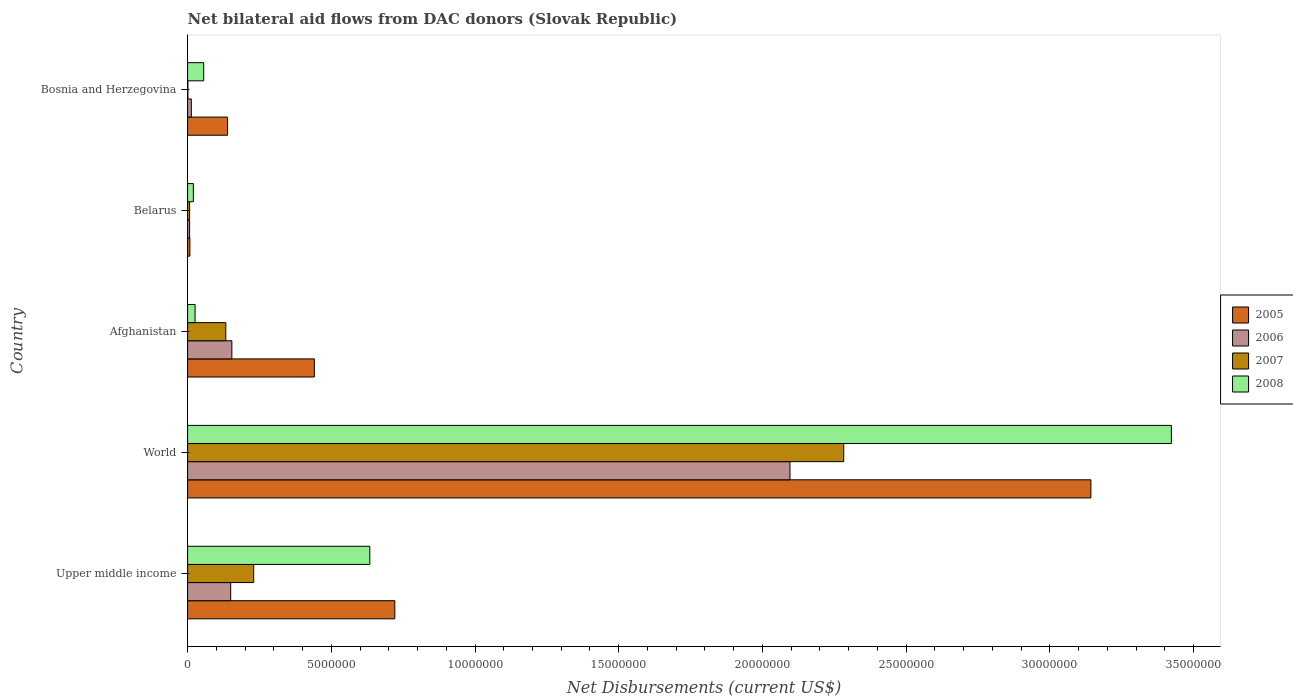How many different coloured bars are there?
Offer a terse response. 4. How many bars are there on the 3rd tick from the bottom?
Your answer should be very brief. 4. What is the label of the 5th group of bars from the top?
Give a very brief answer. Upper middle income. Across all countries, what is the maximum net bilateral aid flows in 2007?
Your answer should be compact. 2.28e+07. In which country was the net bilateral aid flows in 2005 minimum?
Provide a succinct answer. Belarus. What is the total net bilateral aid flows in 2006 in the graph?
Your answer should be very brief. 2.42e+07. What is the difference between the net bilateral aid flows in 2008 in Bosnia and Herzegovina and that in Upper middle income?
Ensure brevity in your answer.  -5.78e+06. What is the difference between the net bilateral aid flows in 2005 in Belarus and the net bilateral aid flows in 2008 in Bosnia and Herzegovina?
Ensure brevity in your answer.  -4.80e+05. What is the average net bilateral aid flows in 2005 per country?
Make the answer very short. 8.90e+06. What is the difference between the net bilateral aid flows in 2007 and net bilateral aid flows in 2006 in Afghanistan?
Provide a short and direct response. -2.10e+05. In how many countries, is the net bilateral aid flows in 2007 greater than 26000000 US$?
Your response must be concise. 0. What is the ratio of the net bilateral aid flows in 2005 in Bosnia and Herzegovina to that in Upper middle income?
Offer a very short reply. 0.19. Is the difference between the net bilateral aid flows in 2007 in Afghanistan and Upper middle income greater than the difference between the net bilateral aid flows in 2006 in Afghanistan and Upper middle income?
Ensure brevity in your answer.  No. What is the difference between the highest and the second highest net bilateral aid flows in 2005?
Make the answer very short. 2.42e+07. What is the difference between the highest and the lowest net bilateral aid flows in 2007?
Your response must be concise. 2.28e+07. Is the sum of the net bilateral aid flows in 2008 in Afghanistan and Bosnia and Herzegovina greater than the maximum net bilateral aid flows in 2005 across all countries?
Provide a succinct answer. No. Is it the case that in every country, the sum of the net bilateral aid flows in 2008 and net bilateral aid flows in 2005 is greater than the sum of net bilateral aid flows in 2007 and net bilateral aid flows in 2006?
Make the answer very short. No. What does the 2nd bar from the bottom in Afghanistan represents?
Provide a succinct answer. 2006. How many bars are there?
Your response must be concise. 20. How many countries are there in the graph?
Ensure brevity in your answer.  5. Where does the legend appear in the graph?
Provide a short and direct response. Center right. What is the title of the graph?
Offer a terse response. Net bilateral aid flows from DAC donors (Slovak Republic). Does "1976" appear as one of the legend labels in the graph?
Offer a terse response. No. What is the label or title of the X-axis?
Ensure brevity in your answer.  Net Disbursements (current US$). What is the Net Disbursements (current US$) in 2005 in Upper middle income?
Provide a succinct answer. 7.21e+06. What is the Net Disbursements (current US$) in 2006 in Upper middle income?
Your answer should be very brief. 1.50e+06. What is the Net Disbursements (current US$) in 2007 in Upper middle income?
Ensure brevity in your answer.  2.30e+06. What is the Net Disbursements (current US$) of 2008 in Upper middle income?
Offer a very short reply. 6.34e+06. What is the Net Disbursements (current US$) in 2005 in World?
Provide a short and direct response. 3.14e+07. What is the Net Disbursements (current US$) of 2006 in World?
Make the answer very short. 2.10e+07. What is the Net Disbursements (current US$) in 2007 in World?
Your answer should be compact. 2.28e+07. What is the Net Disbursements (current US$) of 2008 in World?
Keep it short and to the point. 3.42e+07. What is the Net Disbursements (current US$) in 2005 in Afghanistan?
Provide a short and direct response. 4.41e+06. What is the Net Disbursements (current US$) in 2006 in Afghanistan?
Offer a terse response. 1.54e+06. What is the Net Disbursements (current US$) in 2007 in Afghanistan?
Give a very brief answer. 1.33e+06. What is the Net Disbursements (current US$) of 2008 in Afghanistan?
Make the answer very short. 2.60e+05. What is the Net Disbursements (current US$) of 2005 in Belarus?
Make the answer very short. 8.00e+04. What is the Net Disbursements (current US$) in 2008 in Belarus?
Provide a succinct answer. 2.00e+05. What is the Net Disbursements (current US$) of 2005 in Bosnia and Herzegovina?
Make the answer very short. 1.39e+06. What is the Net Disbursements (current US$) of 2006 in Bosnia and Herzegovina?
Provide a short and direct response. 1.30e+05. What is the Net Disbursements (current US$) in 2008 in Bosnia and Herzegovina?
Keep it short and to the point. 5.60e+05. Across all countries, what is the maximum Net Disbursements (current US$) in 2005?
Ensure brevity in your answer.  3.14e+07. Across all countries, what is the maximum Net Disbursements (current US$) of 2006?
Your answer should be compact. 2.10e+07. Across all countries, what is the maximum Net Disbursements (current US$) in 2007?
Offer a terse response. 2.28e+07. Across all countries, what is the maximum Net Disbursements (current US$) of 2008?
Provide a short and direct response. 3.42e+07. Across all countries, what is the minimum Net Disbursements (current US$) in 2006?
Offer a very short reply. 7.00e+04. Across all countries, what is the minimum Net Disbursements (current US$) of 2008?
Ensure brevity in your answer.  2.00e+05. What is the total Net Disbursements (current US$) in 2005 in the graph?
Provide a succinct answer. 4.45e+07. What is the total Net Disbursements (current US$) of 2006 in the graph?
Ensure brevity in your answer.  2.42e+07. What is the total Net Disbursements (current US$) of 2007 in the graph?
Your answer should be compact. 2.65e+07. What is the total Net Disbursements (current US$) in 2008 in the graph?
Ensure brevity in your answer.  4.16e+07. What is the difference between the Net Disbursements (current US$) of 2005 in Upper middle income and that in World?
Keep it short and to the point. -2.42e+07. What is the difference between the Net Disbursements (current US$) in 2006 in Upper middle income and that in World?
Ensure brevity in your answer.  -1.95e+07. What is the difference between the Net Disbursements (current US$) of 2007 in Upper middle income and that in World?
Ensure brevity in your answer.  -2.05e+07. What is the difference between the Net Disbursements (current US$) in 2008 in Upper middle income and that in World?
Make the answer very short. -2.79e+07. What is the difference between the Net Disbursements (current US$) of 2005 in Upper middle income and that in Afghanistan?
Your response must be concise. 2.80e+06. What is the difference between the Net Disbursements (current US$) in 2007 in Upper middle income and that in Afghanistan?
Your answer should be very brief. 9.70e+05. What is the difference between the Net Disbursements (current US$) of 2008 in Upper middle income and that in Afghanistan?
Offer a terse response. 6.08e+06. What is the difference between the Net Disbursements (current US$) of 2005 in Upper middle income and that in Belarus?
Keep it short and to the point. 7.13e+06. What is the difference between the Net Disbursements (current US$) in 2006 in Upper middle income and that in Belarus?
Make the answer very short. 1.43e+06. What is the difference between the Net Disbursements (current US$) in 2007 in Upper middle income and that in Belarus?
Offer a very short reply. 2.23e+06. What is the difference between the Net Disbursements (current US$) in 2008 in Upper middle income and that in Belarus?
Your answer should be very brief. 6.14e+06. What is the difference between the Net Disbursements (current US$) of 2005 in Upper middle income and that in Bosnia and Herzegovina?
Your answer should be compact. 5.82e+06. What is the difference between the Net Disbursements (current US$) of 2006 in Upper middle income and that in Bosnia and Herzegovina?
Provide a succinct answer. 1.37e+06. What is the difference between the Net Disbursements (current US$) of 2007 in Upper middle income and that in Bosnia and Herzegovina?
Provide a succinct answer. 2.29e+06. What is the difference between the Net Disbursements (current US$) in 2008 in Upper middle income and that in Bosnia and Herzegovina?
Your response must be concise. 5.78e+06. What is the difference between the Net Disbursements (current US$) of 2005 in World and that in Afghanistan?
Your answer should be very brief. 2.70e+07. What is the difference between the Net Disbursements (current US$) in 2006 in World and that in Afghanistan?
Make the answer very short. 1.94e+07. What is the difference between the Net Disbursements (current US$) of 2007 in World and that in Afghanistan?
Give a very brief answer. 2.15e+07. What is the difference between the Net Disbursements (current US$) of 2008 in World and that in Afghanistan?
Keep it short and to the point. 3.40e+07. What is the difference between the Net Disbursements (current US$) of 2005 in World and that in Belarus?
Your answer should be very brief. 3.14e+07. What is the difference between the Net Disbursements (current US$) of 2006 in World and that in Belarus?
Provide a short and direct response. 2.09e+07. What is the difference between the Net Disbursements (current US$) in 2007 in World and that in Belarus?
Your response must be concise. 2.28e+07. What is the difference between the Net Disbursements (current US$) of 2008 in World and that in Belarus?
Provide a succinct answer. 3.40e+07. What is the difference between the Net Disbursements (current US$) of 2005 in World and that in Bosnia and Herzegovina?
Offer a very short reply. 3.00e+07. What is the difference between the Net Disbursements (current US$) in 2006 in World and that in Bosnia and Herzegovina?
Provide a short and direct response. 2.08e+07. What is the difference between the Net Disbursements (current US$) of 2007 in World and that in Bosnia and Herzegovina?
Keep it short and to the point. 2.28e+07. What is the difference between the Net Disbursements (current US$) of 2008 in World and that in Bosnia and Herzegovina?
Provide a short and direct response. 3.37e+07. What is the difference between the Net Disbursements (current US$) in 2005 in Afghanistan and that in Belarus?
Offer a very short reply. 4.33e+06. What is the difference between the Net Disbursements (current US$) in 2006 in Afghanistan and that in Belarus?
Provide a succinct answer. 1.47e+06. What is the difference between the Net Disbursements (current US$) of 2007 in Afghanistan and that in Belarus?
Provide a succinct answer. 1.26e+06. What is the difference between the Net Disbursements (current US$) in 2005 in Afghanistan and that in Bosnia and Herzegovina?
Offer a very short reply. 3.02e+06. What is the difference between the Net Disbursements (current US$) in 2006 in Afghanistan and that in Bosnia and Herzegovina?
Your response must be concise. 1.41e+06. What is the difference between the Net Disbursements (current US$) of 2007 in Afghanistan and that in Bosnia and Herzegovina?
Your answer should be compact. 1.32e+06. What is the difference between the Net Disbursements (current US$) of 2005 in Belarus and that in Bosnia and Herzegovina?
Provide a short and direct response. -1.31e+06. What is the difference between the Net Disbursements (current US$) in 2006 in Belarus and that in Bosnia and Herzegovina?
Give a very brief answer. -6.00e+04. What is the difference between the Net Disbursements (current US$) in 2008 in Belarus and that in Bosnia and Herzegovina?
Provide a succinct answer. -3.60e+05. What is the difference between the Net Disbursements (current US$) of 2005 in Upper middle income and the Net Disbursements (current US$) of 2006 in World?
Your answer should be compact. -1.38e+07. What is the difference between the Net Disbursements (current US$) of 2005 in Upper middle income and the Net Disbursements (current US$) of 2007 in World?
Make the answer very short. -1.56e+07. What is the difference between the Net Disbursements (current US$) of 2005 in Upper middle income and the Net Disbursements (current US$) of 2008 in World?
Ensure brevity in your answer.  -2.70e+07. What is the difference between the Net Disbursements (current US$) of 2006 in Upper middle income and the Net Disbursements (current US$) of 2007 in World?
Your answer should be very brief. -2.13e+07. What is the difference between the Net Disbursements (current US$) in 2006 in Upper middle income and the Net Disbursements (current US$) in 2008 in World?
Keep it short and to the point. -3.27e+07. What is the difference between the Net Disbursements (current US$) in 2007 in Upper middle income and the Net Disbursements (current US$) in 2008 in World?
Your answer should be very brief. -3.19e+07. What is the difference between the Net Disbursements (current US$) in 2005 in Upper middle income and the Net Disbursements (current US$) in 2006 in Afghanistan?
Your answer should be very brief. 5.67e+06. What is the difference between the Net Disbursements (current US$) in 2005 in Upper middle income and the Net Disbursements (current US$) in 2007 in Afghanistan?
Keep it short and to the point. 5.88e+06. What is the difference between the Net Disbursements (current US$) of 2005 in Upper middle income and the Net Disbursements (current US$) of 2008 in Afghanistan?
Your answer should be very brief. 6.95e+06. What is the difference between the Net Disbursements (current US$) of 2006 in Upper middle income and the Net Disbursements (current US$) of 2008 in Afghanistan?
Ensure brevity in your answer.  1.24e+06. What is the difference between the Net Disbursements (current US$) of 2007 in Upper middle income and the Net Disbursements (current US$) of 2008 in Afghanistan?
Provide a succinct answer. 2.04e+06. What is the difference between the Net Disbursements (current US$) in 2005 in Upper middle income and the Net Disbursements (current US$) in 2006 in Belarus?
Ensure brevity in your answer.  7.14e+06. What is the difference between the Net Disbursements (current US$) in 2005 in Upper middle income and the Net Disbursements (current US$) in 2007 in Belarus?
Make the answer very short. 7.14e+06. What is the difference between the Net Disbursements (current US$) in 2005 in Upper middle income and the Net Disbursements (current US$) in 2008 in Belarus?
Keep it short and to the point. 7.01e+06. What is the difference between the Net Disbursements (current US$) in 2006 in Upper middle income and the Net Disbursements (current US$) in 2007 in Belarus?
Offer a terse response. 1.43e+06. What is the difference between the Net Disbursements (current US$) of 2006 in Upper middle income and the Net Disbursements (current US$) of 2008 in Belarus?
Make the answer very short. 1.30e+06. What is the difference between the Net Disbursements (current US$) of 2007 in Upper middle income and the Net Disbursements (current US$) of 2008 in Belarus?
Provide a short and direct response. 2.10e+06. What is the difference between the Net Disbursements (current US$) in 2005 in Upper middle income and the Net Disbursements (current US$) in 2006 in Bosnia and Herzegovina?
Your answer should be very brief. 7.08e+06. What is the difference between the Net Disbursements (current US$) in 2005 in Upper middle income and the Net Disbursements (current US$) in 2007 in Bosnia and Herzegovina?
Provide a succinct answer. 7.20e+06. What is the difference between the Net Disbursements (current US$) in 2005 in Upper middle income and the Net Disbursements (current US$) in 2008 in Bosnia and Herzegovina?
Make the answer very short. 6.65e+06. What is the difference between the Net Disbursements (current US$) in 2006 in Upper middle income and the Net Disbursements (current US$) in 2007 in Bosnia and Herzegovina?
Give a very brief answer. 1.49e+06. What is the difference between the Net Disbursements (current US$) in 2006 in Upper middle income and the Net Disbursements (current US$) in 2008 in Bosnia and Herzegovina?
Keep it short and to the point. 9.40e+05. What is the difference between the Net Disbursements (current US$) of 2007 in Upper middle income and the Net Disbursements (current US$) of 2008 in Bosnia and Herzegovina?
Keep it short and to the point. 1.74e+06. What is the difference between the Net Disbursements (current US$) of 2005 in World and the Net Disbursements (current US$) of 2006 in Afghanistan?
Your answer should be very brief. 2.99e+07. What is the difference between the Net Disbursements (current US$) of 2005 in World and the Net Disbursements (current US$) of 2007 in Afghanistan?
Offer a terse response. 3.01e+07. What is the difference between the Net Disbursements (current US$) of 2005 in World and the Net Disbursements (current US$) of 2008 in Afghanistan?
Make the answer very short. 3.12e+07. What is the difference between the Net Disbursements (current US$) of 2006 in World and the Net Disbursements (current US$) of 2007 in Afghanistan?
Make the answer very short. 1.96e+07. What is the difference between the Net Disbursements (current US$) in 2006 in World and the Net Disbursements (current US$) in 2008 in Afghanistan?
Your answer should be very brief. 2.07e+07. What is the difference between the Net Disbursements (current US$) of 2007 in World and the Net Disbursements (current US$) of 2008 in Afghanistan?
Provide a succinct answer. 2.26e+07. What is the difference between the Net Disbursements (current US$) of 2005 in World and the Net Disbursements (current US$) of 2006 in Belarus?
Your answer should be very brief. 3.14e+07. What is the difference between the Net Disbursements (current US$) in 2005 in World and the Net Disbursements (current US$) in 2007 in Belarus?
Keep it short and to the point. 3.14e+07. What is the difference between the Net Disbursements (current US$) of 2005 in World and the Net Disbursements (current US$) of 2008 in Belarus?
Your answer should be compact. 3.12e+07. What is the difference between the Net Disbursements (current US$) in 2006 in World and the Net Disbursements (current US$) in 2007 in Belarus?
Offer a very short reply. 2.09e+07. What is the difference between the Net Disbursements (current US$) of 2006 in World and the Net Disbursements (current US$) of 2008 in Belarus?
Your answer should be very brief. 2.08e+07. What is the difference between the Net Disbursements (current US$) in 2007 in World and the Net Disbursements (current US$) in 2008 in Belarus?
Offer a terse response. 2.26e+07. What is the difference between the Net Disbursements (current US$) of 2005 in World and the Net Disbursements (current US$) of 2006 in Bosnia and Herzegovina?
Your answer should be very brief. 3.13e+07. What is the difference between the Net Disbursements (current US$) in 2005 in World and the Net Disbursements (current US$) in 2007 in Bosnia and Herzegovina?
Provide a succinct answer. 3.14e+07. What is the difference between the Net Disbursements (current US$) of 2005 in World and the Net Disbursements (current US$) of 2008 in Bosnia and Herzegovina?
Keep it short and to the point. 3.09e+07. What is the difference between the Net Disbursements (current US$) of 2006 in World and the Net Disbursements (current US$) of 2007 in Bosnia and Herzegovina?
Give a very brief answer. 2.10e+07. What is the difference between the Net Disbursements (current US$) in 2006 in World and the Net Disbursements (current US$) in 2008 in Bosnia and Herzegovina?
Give a very brief answer. 2.04e+07. What is the difference between the Net Disbursements (current US$) of 2007 in World and the Net Disbursements (current US$) of 2008 in Bosnia and Herzegovina?
Ensure brevity in your answer.  2.23e+07. What is the difference between the Net Disbursements (current US$) of 2005 in Afghanistan and the Net Disbursements (current US$) of 2006 in Belarus?
Give a very brief answer. 4.34e+06. What is the difference between the Net Disbursements (current US$) in 2005 in Afghanistan and the Net Disbursements (current US$) in 2007 in Belarus?
Make the answer very short. 4.34e+06. What is the difference between the Net Disbursements (current US$) of 2005 in Afghanistan and the Net Disbursements (current US$) of 2008 in Belarus?
Give a very brief answer. 4.21e+06. What is the difference between the Net Disbursements (current US$) in 2006 in Afghanistan and the Net Disbursements (current US$) in 2007 in Belarus?
Give a very brief answer. 1.47e+06. What is the difference between the Net Disbursements (current US$) in 2006 in Afghanistan and the Net Disbursements (current US$) in 2008 in Belarus?
Your response must be concise. 1.34e+06. What is the difference between the Net Disbursements (current US$) in 2007 in Afghanistan and the Net Disbursements (current US$) in 2008 in Belarus?
Offer a very short reply. 1.13e+06. What is the difference between the Net Disbursements (current US$) of 2005 in Afghanistan and the Net Disbursements (current US$) of 2006 in Bosnia and Herzegovina?
Offer a terse response. 4.28e+06. What is the difference between the Net Disbursements (current US$) of 2005 in Afghanistan and the Net Disbursements (current US$) of 2007 in Bosnia and Herzegovina?
Provide a succinct answer. 4.40e+06. What is the difference between the Net Disbursements (current US$) in 2005 in Afghanistan and the Net Disbursements (current US$) in 2008 in Bosnia and Herzegovina?
Offer a terse response. 3.85e+06. What is the difference between the Net Disbursements (current US$) in 2006 in Afghanistan and the Net Disbursements (current US$) in 2007 in Bosnia and Herzegovina?
Your answer should be compact. 1.53e+06. What is the difference between the Net Disbursements (current US$) of 2006 in Afghanistan and the Net Disbursements (current US$) of 2008 in Bosnia and Herzegovina?
Your answer should be very brief. 9.80e+05. What is the difference between the Net Disbursements (current US$) of 2007 in Afghanistan and the Net Disbursements (current US$) of 2008 in Bosnia and Herzegovina?
Make the answer very short. 7.70e+05. What is the difference between the Net Disbursements (current US$) in 2005 in Belarus and the Net Disbursements (current US$) in 2007 in Bosnia and Herzegovina?
Provide a short and direct response. 7.00e+04. What is the difference between the Net Disbursements (current US$) of 2005 in Belarus and the Net Disbursements (current US$) of 2008 in Bosnia and Herzegovina?
Your response must be concise. -4.80e+05. What is the difference between the Net Disbursements (current US$) in 2006 in Belarus and the Net Disbursements (current US$) in 2008 in Bosnia and Herzegovina?
Your response must be concise. -4.90e+05. What is the difference between the Net Disbursements (current US$) in 2007 in Belarus and the Net Disbursements (current US$) in 2008 in Bosnia and Herzegovina?
Provide a succinct answer. -4.90e+05. What is the average Net Disbursements (current US$) of 2005 per country?
Give a very brief answer. 8.90e+06. What is the average Net Disbursements (current US$) of 2006 per country?
Your answer should be compact. 4.84e+06. What is the average Net Disbursements (current US$) in 2007 per country?
Give a very brief answer. 5.31e+06. What is the average Net Disbursements (current US$) of 2008 per country?
Make the answer very short. 8.32e+06. What is the difference between the Net Disbursements (current US$) of 2005 and Net Disbursements (current US$) of 2006 in Upper middle income?
Provide a short and direct response. 5.71e+06. What is the difference between the Net Disbursements (current US$) of 2005 and Net Disbursements (current US$) of 2007 in Upper middle income?
Your answer should be very brief. 4.91e+06. What is the difference between the Net Disbursements (current US$) of 2005 and Net Disbursements (current US$) of 2008 in Upper middle income?
Your answer should be very brief. 8.70e+05. What is the difference between the Net Disbursements (current US$) of 2006 and Net Disbursements (current US$) of 2007 in Upper middle income?
Provide a short and direct response. -8.00e+05. What is the difference between the Net Disbursements (current US$) in 2006 and Net Disbursements (current US$) in 2008 in Upper middle income?
Ensure brevity in your answer.  -4.84e+06. What is the difference between the Net Disbursements (current US$) in 2007 and Net Disbursements (current US$) in 2008 in Upper middle income?
Offer a terse response. -4.04e+06. What is the difference between the Net Disbursements (current US$) in 2005 and Net Disbursements (current US$) in 2006 in World?
Make the answer very short. 1.05e+07. What is the difference between the Net Disbursements (current US$) of 2005 and Net Disbursements (current US$) of 2007 in World?
Your response must be concise. 8.60e+06. What is the difference between the Net Disbursements (current US$) of 2005 and Net Disbursements (current US$) of 2008 in World?
Make the answer very short. -2.80e+06. What is the difference between the Net Disbursements (current US$) of 2006 and Net Disbursements (current US$) of 2007 in World?
Keep it short and to the point. -1.87e+06. What is the difference between the Net Disbursements (current US$) in 2006 and Net Disbursements (current US$) in 2008 in World?
Give a very brief answer. -1.33e+07. What is the difference between the Net Disbursements (current US$) of 2007 and Net Disbursements (current US$) of 2008 in World?
Make the answer very short. -1.14e+07. What is the difference between the Net Disbursements (current US$) of 2005 and Net Disbursements (current US$) of 2006 in Afghanistan?
Give a very brief answer. 2.87e+06. What is the difference between the Net Disbursements (current US$) in 2005 and Net Disbursements (current US$) in 2007 in Afghanistan?
Ensure brevity in your answer.  3.08e+06. What is the difference between the Net Disbursements (current US$) of 2005 and Net Disbursements (current US$) of 2008 in Afghanistan?
Keep it short and to the point. 4.15e+06. What is the difference between the Net Disbursements (current US$) in 2006 and Net Disbursements (current US$) in 2007 in Afghanistan?
Provide a short and direct response. 2.10e+05. What is the difference between the Net Disbursements (current US$) in 2006 and Net Disbursements (current US$) in 2008 in Afghanistan?
Your response must be concise. 1.28e+06. What is the difference between the Net Disbursements (current US$) in 2007 and Net Disbursements (current US$) in 2008 in Afghanistan?
Keep it short and to the point. 1.07e+06. What is the difference between the Net Disbursements (current US$) of 2005 and Net Disbursements (current US$) of 2006 in Belarus?
Ensure brevity in your answer.  10000. What is the difference between the Net Disbursements (current US$) of 2005 and Net Disbursements (current US$) of 2007 in Belarus?
Your answer should be compact. 10000. What is the difference between the Net Disbursements (current US$) of 2005 and Net Disbursements (current US$) of 2008 in Belarus?
Provide a short and direct response. -1.20e+05. What is the difference between the Net Disbursements (current US$) of 2006 and Net Disbursements (current US$) of 2007 in Belarus?
Your response must be concise. 0. What is the difference between the Net Disbursements (current US$) of 2006 and Net Disbursements (current US$) of 2008 in Belarus?
Offer a very short reply. -1.30e+05. What is the difference between the Net Disbursements (current US$) in 2007 and Net Disbursements (current US$) in 2008 in Belarus?
Provide a short and direct response. -1.30e+05. What is the difference between the Net Disbursements (current US$) in 2005 and Net Disbursements (current US$) in 2006 in Bosnia and Herzegovina?
Your response must be concise. 1.26e+06. What is the difference between the Net Disbursements (current US$) in 2005 and Net Disbursements (current US$) in 2007 in Bosnia and Herzegovina?
Offer a very short reply. 1.38e+06. What is the difference between the Net Disbursements (current US$) in 2005 and Net Disbursements (current US$) in 2008 in Bosnia and Herzegovina?
Keep it short and to the point. 8.30e+05. What is the difference between the Net Disbursements (current US$) in 2006 and Net Disbursements (current US$) in 2008 in Bosnia and Herzegovina?
Offer a very short reply. -4.30e+05. What is the difference between the Net Disbursements (current US$) of 2007 and Net Disbursements (current US$) of 2008 in Bosnia and Herzegovina?
Make the answer very short. -5.50e+05. What is the ratio of the Net Disbursements (current US$) of 2005 in Upper middle income to that in World?
Ensure brevity in your answer.  0.23. What is the ratio of the Net Disbursements (current US$) of 2006 in Upper middle income to that in World?
Provide a short and direct response. 0.07. What is the ratio of the Net Disbursements (current US$) in 2007 in Upper middle income to that in World?
Make the answer very short. 0.1. What is the ratio of the Net Disbursements (current US$) in 2008 in Upper middle income to that in World?
Provide a succinct answer. 0.19. What is the ratio of the Net Disbursements (current US$) in 2005 in Upper middle income to that in Afghanistan?
Your answer should be compact. 1.63. What is the ratio of the Net Disbursements (current US$) in 2007 in Upper middle income to that in Afghanistan?
Provide a succinct answer. 1.73. What is the ratio of the Net Disbursements (current US$) of 2008 in Upper middle income to that in Afghanistan?
Your answer should be compact. 24.38. What is the ratio of the Net Disbursements (current US$) of 2005 in Upper middle income to that in Belarus?
Your answer should be very brief. 90.12. What is the ratio of the Net Disbursements (current US$) of 2006 in Upper middle income to that in Belarus?
Offer a very short reply. 21.43. What is the ratio of the Net Disbursements (current US$) in 2007 in Upper middle income to that in Belarus?
Provide a succinct answer. 32.86. What is the ratio of the Net Disbursements (current US$) of 2008 in Upper middle income to that in Belarus?
Offer a terse response. 31.7. What is the ratio of the Net Disbursements (current US$) in 2005 in Upper middle income to that in Bosnia and Herzegovina?
Offer a terse response. 5.19. What is the ratio of the Net Disbursements (current US$) in 2006 in Upper middle income to that in Bosnia and Herzegovina?
Offer a terse response. 11.54. What is the ratio of the Net Disbursements (current US$) in 2007 in Upper middle income to that in Bosnia and Herzegovina?
Give a very brief answer. 230. What is the ratio of the Net Disbursements (current US$) in 2008 in Upper middle income to that in Bosnia and Herzegovina?
Offer a terse response. 11.32. What is the ratio of the Net Disbursements (current US$) of 2005 in World to that in Afghanistan?
Make the answer very short. 7.13. What is the ratio of the Net Disbursements (current US$) in 2006 in World to that in Afghanistan?
Keep it short and to the point. 13.61. What is the ratio of the Net Disbursements (current US$) in 2007 in World to that in Afghanistan?
Your response must be concise. 17.17. What is the ratio of the Net Disbursements (current US$) of 2008 in World to that in Afghanistan?
Provide a succinct answer. 131.65. What is the ratio of the Net Disbursements (current US$) of 2005 in World to that in Belarus?
Offer a terse response. 392.88. What is the ratio of the Net Disbursements (current US$) in 2006 in World to that in Belarus?
Give a very brief answer. 299.43. What is the ratio of the Net Disbursements (current US$) in 2007 in World to that in Belarus?
Offer a very short reply. 326.14. What is the ratio of the Net Disbursements (current US$) of 2008 in World to that in Belarus?
Your response must be concise. 171.15. What is the ratio of the Net Disbursements (current US$) in 2005 in World to that in Bosnia and Herzegovina?
Ensure brevity in your answer.  22.61. What is the ratio of the Net Disbursements (current US$) of 2006 in World to that in Bosnia and Herzegovina?
Give a very brief answer. 161.23. What is the ratio of the Net Disbursements (current US$) in 2007 in World to that in Bosnia and Herzegovina?
Your answer should be compact. 2283. What is the ratio of the Net Disbursements (current US$) of 2008 in World to that in Bosnia and Herzegovina?
Make the answer very short. 61.12. What is the ratio of the Net Disbursements (current US$) in 2005 in Afghanistan to that in Belarus?
Your answer should be compact. 55.12. What is the ratio of the Net Disbursements (current US$) of 2005 in Afghanistan to that in Bosnia and Herzegovina?
Provide a short and direct response. 3.17. What is the ratio of the Net Disbursements (current US$) of 2006 in Afghanistan to that in Bosnia and Herzegovina?
Keep it short and to the point. 11.85. What is the ratio of the Net Disbursements (current US$) of 2007 in Afghanistan to that in Bosnia and Herzegovina?
Your answer should be very brief. 133. What is the ratio of the Net Disbursements (current US$) in 2008 in Afghanistan to that in Bosnia and Herzegovina?
Ensure brevity in your answer.  0.46. What is the ratio of the Net Disbursements (current US$) of 2005 in Belarus to that in Bosnia and Herzegovina?
Your answer should be compact. 0.06. What is the ratio of the Net Disbursements (current US$) in 2006 in Belarus to that in Bosnia and Herzegovina?
Provide a short and direct response. 0.54. What is the ratio of the Net Disbursements (current US$) in 2008 in Belarus to that in Bosnia and Herzegovina?
Keep it short and to the point. 0.36. What is the difference between the highest and the second highest Net Disbursements (current US$) in 2005?
Your answer should be compact. 2.42e+07. What is the difference between the highest and the second highest Net Disbursements (current US$) of 2006?
Offer a terse response. 1.94e+07. What is the difference between the highest and the second highest Net Disbursements (current US$) of 2007?
Provide a short and direct response. 2.05e+07. What is the difference between the highest and the second highest Net Disbursements (current US$) in 2008?
Offer a very short reply. 2.79e+07. What is the difference between the highest and the lowest Net Disbursements (current US$) in 2005?
Keep it short and to the point. 3.14e+07. What is the difference between the highest and the lowest Net Disbursements (current US$) in 2006?
Provide a succinct answer. 2.09e+07. What is the difference between the highest and the lowest Net Disbursements (current US$) of 2007?
Offer a terse response. 2.28e+07. What is the difference between the highest and the lowest Net Disbursements (current US$) of 2008?
Give a very brief answer. 3.40e+07. 